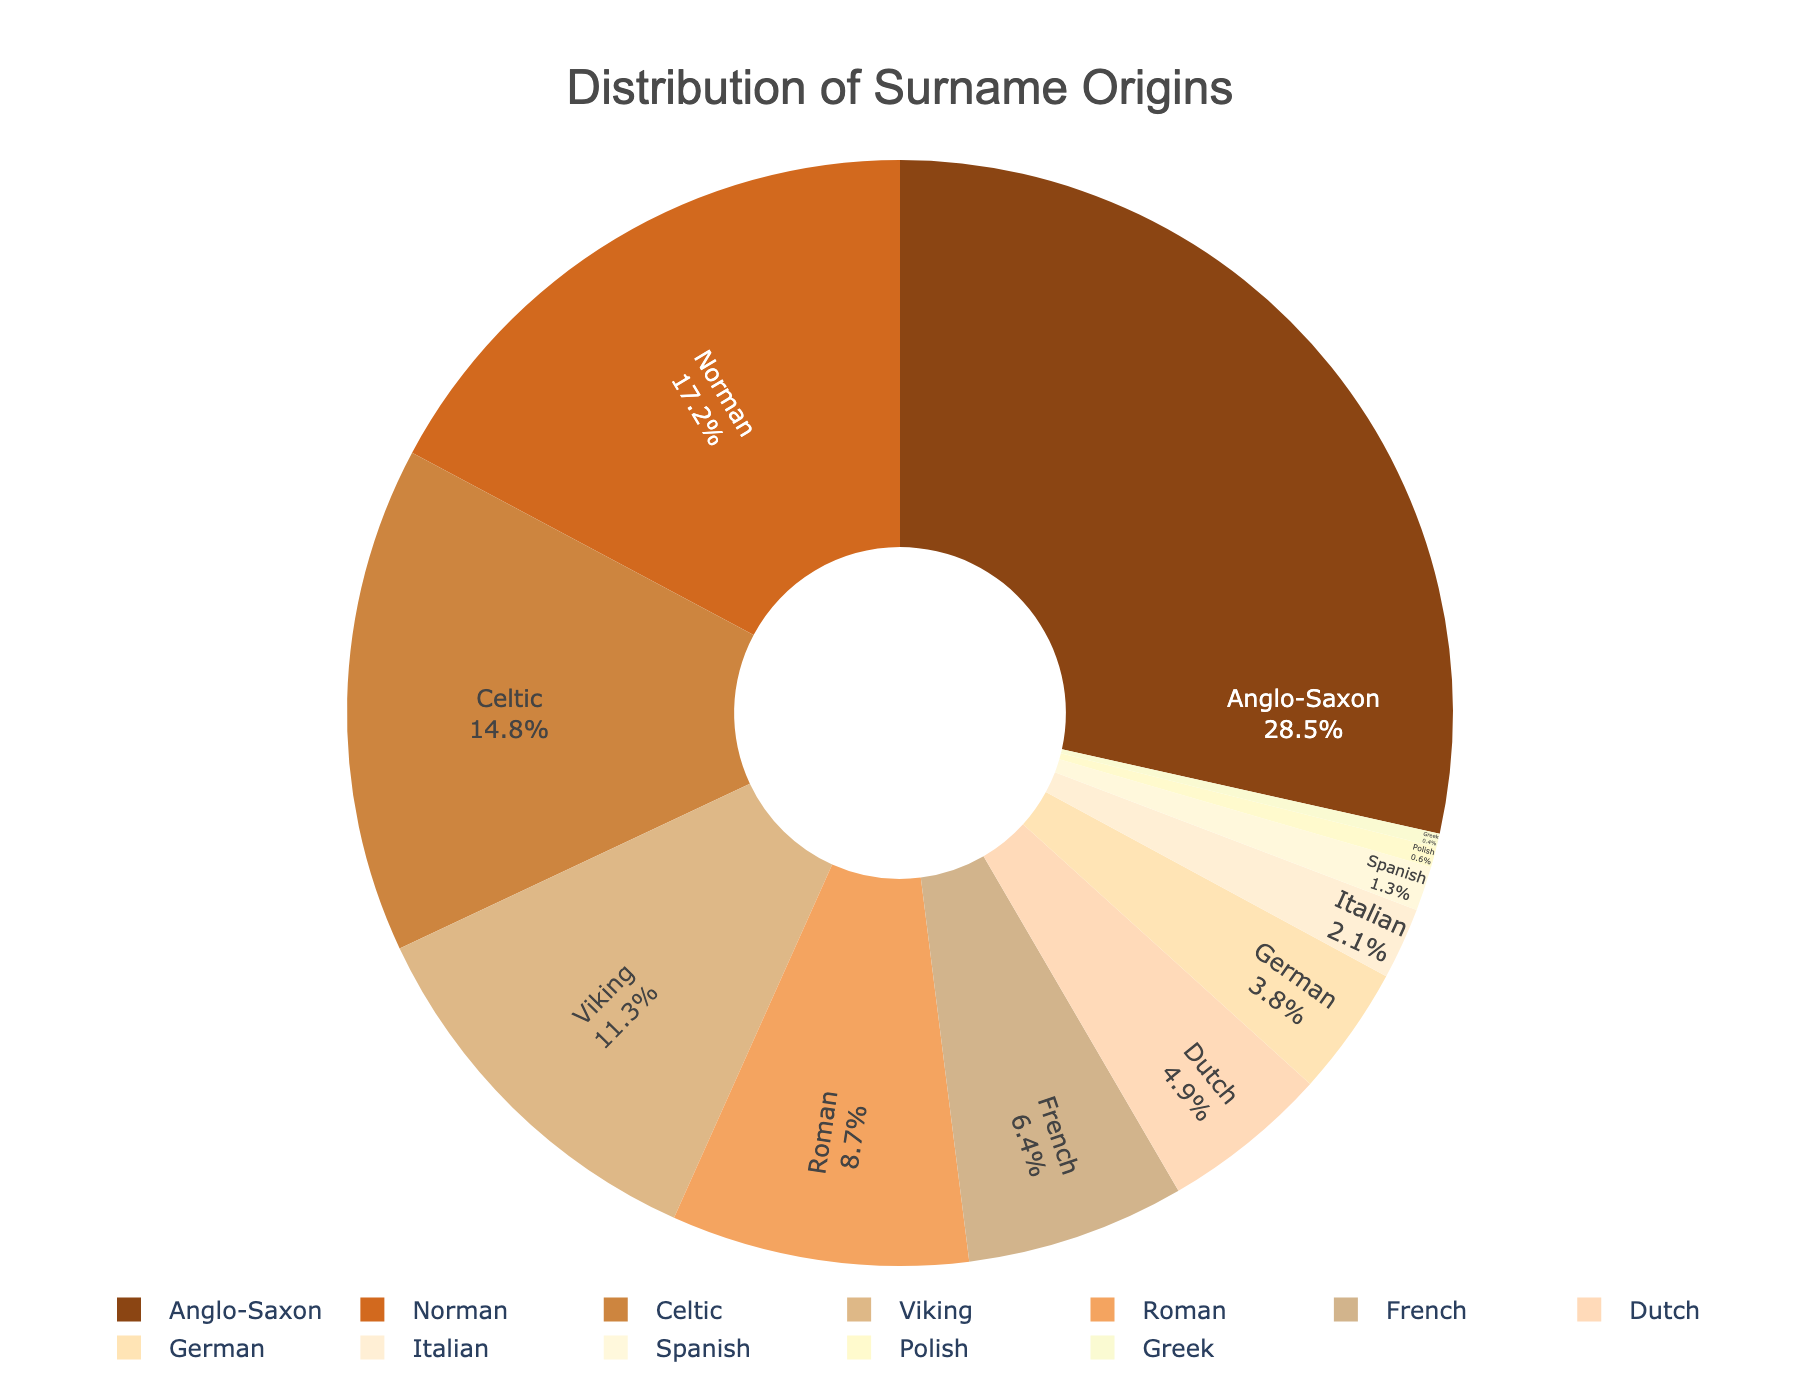Which surname origin has the highest percentage? Look at the pie chart and identify the slice corresponding to the largest percentage. The Anglo-Saxon origin slice is the largest, accounting for 28.5%.
Answer: Anglo-Saxon What is the combined percentage of Viking and Roman surnames? Locate the slices for Viking and Roman origins on the pie chart. Add their percentages together: Viking (11.3%) + Roman (8.7%) = 20%.
Answer: 20% How much more common are Anglo-Saxon surnames compared to Italian surnames? Compare the percentages of Anglo-Saxon (28.5%) and Italian (2.1%) origins. Subtract the smaller percentage from the larger one: 28.5% - 2.1% = 26.4%.
Answer: 26.4% Which surname origin is represented by the yellowish slice? Identify the yellowish slice color on the pie chart, which corresponds to a particular surname origin. The yellowish slice represents the French origin with 6.4%.
Answer: French Are there more Norman or Celtic surname origins? Compare the sizes of the slices for Norman and Celtic origins. Norman has 17.2%, while Celtic has 14.8%. Therefore, Norman is more common.
Answer: Norman What is the total percentage of surname origins that are less common than Norman? Identify all percentages for origins less common than Norman (17.2%): Celtic (14.8%), Viking (11.3%), Roman (8.7%), French (6.4%), Dutch (4.9%), German (3.8%), Italian (2.1%), Spanish (1.3%), Polish (0.6%), Greek (0.4%). Sum these percentages: 14.8% + 11.3% + 8.7% + 6.4% + 4.9% + 3.8% + 2.1% + 1.3% + 0.6% + 0.4% = 54.3%.
Answer: 54.3% What percentage of surname origins are from Germanic roots (German and Dutch)? Add the percentages of German (3.8%) and Dutch (4.9%) origins: 3.8% + 4.9% = 8.7%.
Answer: 8.7% Which is smaller: the sum of French and German surname origins, or the sum of Celtic and Viking surname origins? Calculate the sum of French (6.4%) and German (3.8%) origins: 6.4% + 3.8% = 10.2%. Calculate the sum of Celtic (14.8%) and Viking (11.3%) origins: 14.8% + 11.3% = 26.1%. The sum of French and German is smaller.
Answer: French and German What is the difference in percentage between the most and the second most common surname origins? Identify the most common (Anglo-Saxon, 28.5%) and the second most common (Norman, 17.2%) origins. Subtract the second most common percentage from the most common: 28.5% - 17.2% = 11.3%.
Answer: 11.3% Is there any surname origin that makes up less than 1% of the total distribution? Look at the pie chart to find any slices representing less than 1%. Both Polish (0.6%) and Greek (0.4%) surnames are less than 1%.
Answer: Yes 